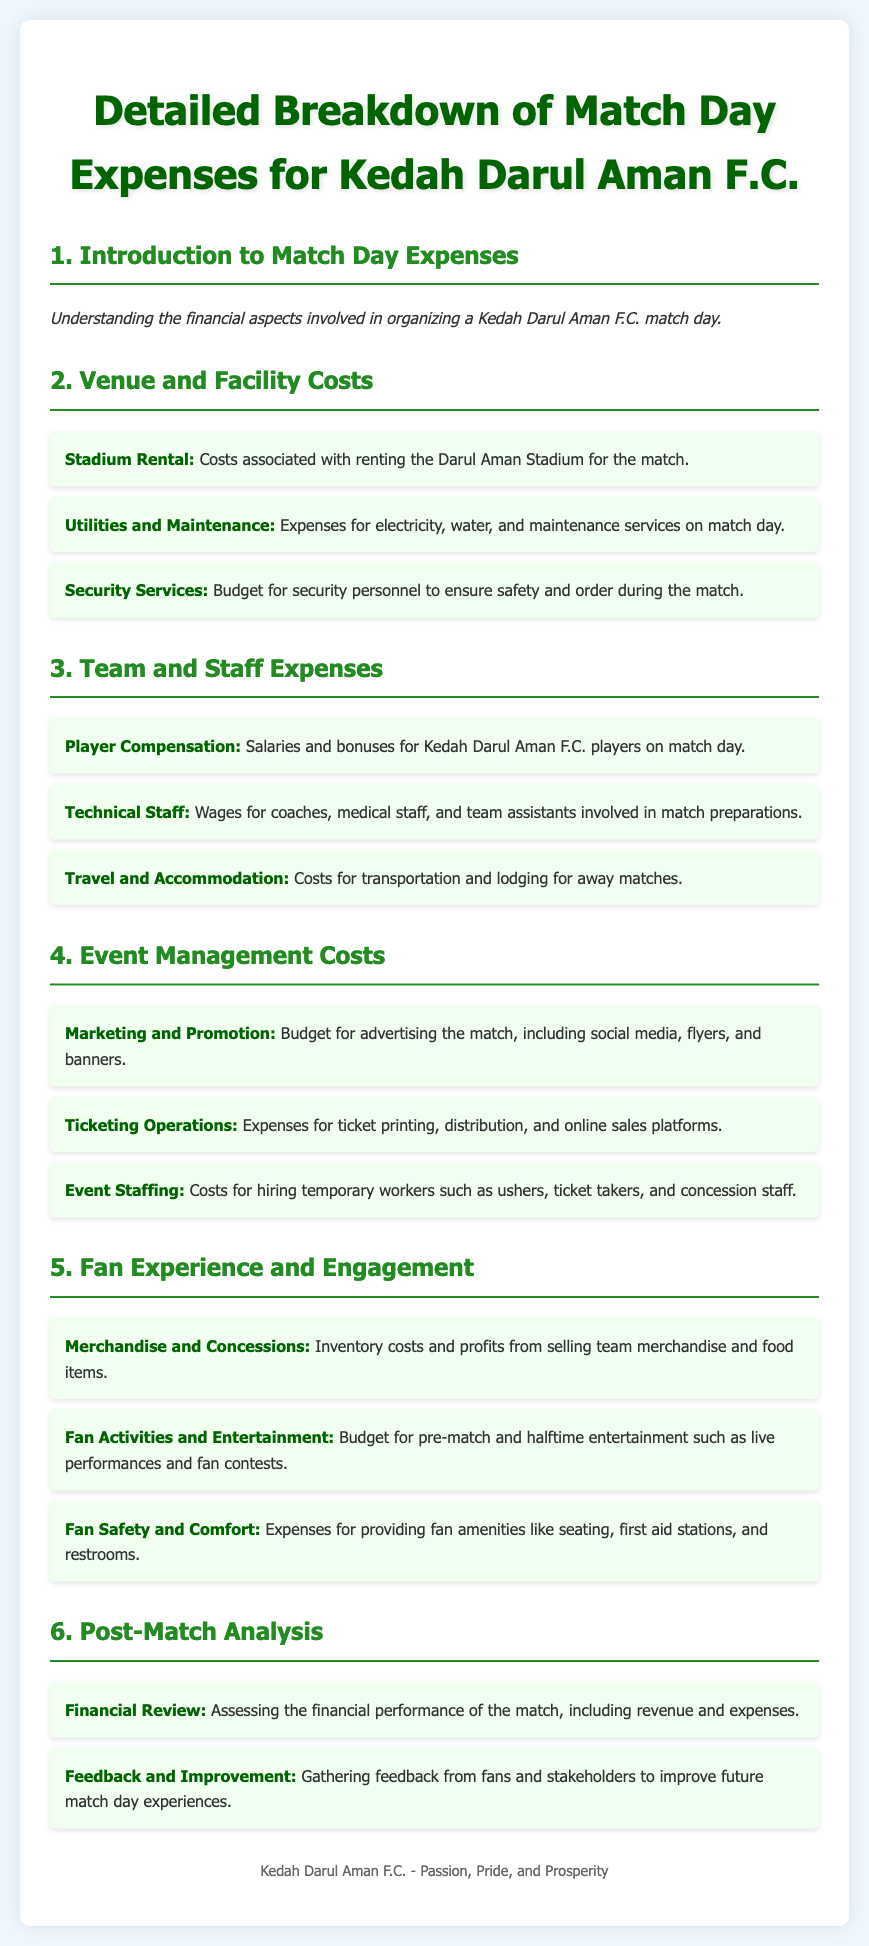What is the title of the syllabus? The title is stated at the top of the document and reflects the main subject of the syllabus.
Answer: Detailed Breakdown of Match Day Expenses for Kedah Darul Aman F.C What expenses are included under Venue and Facility Costs? The document lists specific expenses related to the venue and facility, such as stadium rental and utilities.
Answer: Stadium Rental, Utilities and Maintenance, Security Services What is the focus of the section on Team and Staff Expenses? The section details the financial aspects related to the players and staff associated with Kedah Darul Aman F.C.
Answer: Player Compensation, Technical Staff, Travel and Accommodation How many main sections are there in the syllabus? The number of main sections is counted from the headings present in the document.
Answer: Six What is one type of expense related to Event Management Costs? The document provides multiple examples of expenses, and one of them is specifically mentioned under this category.
Answer: Marketing and Promotion What aspect of the match day does the Fan Experience and Engagement section cover? This section describes various expenses related to enhancing the experience for fans during the match.
Answer: Merchandise and Concessions, Fan Activities and Entertainment, Fan Safety and Comfort What is the purpose of the Post-Match Analysis section? This section is meant to evaluate the financial outcomes and gather feedback after the match.
Answer: Financial Review, Feedback and Improvement Which color is primarily used for the headings? The color used in the headings can be noted from the styling defined in the document.
Answer: Dark Green 